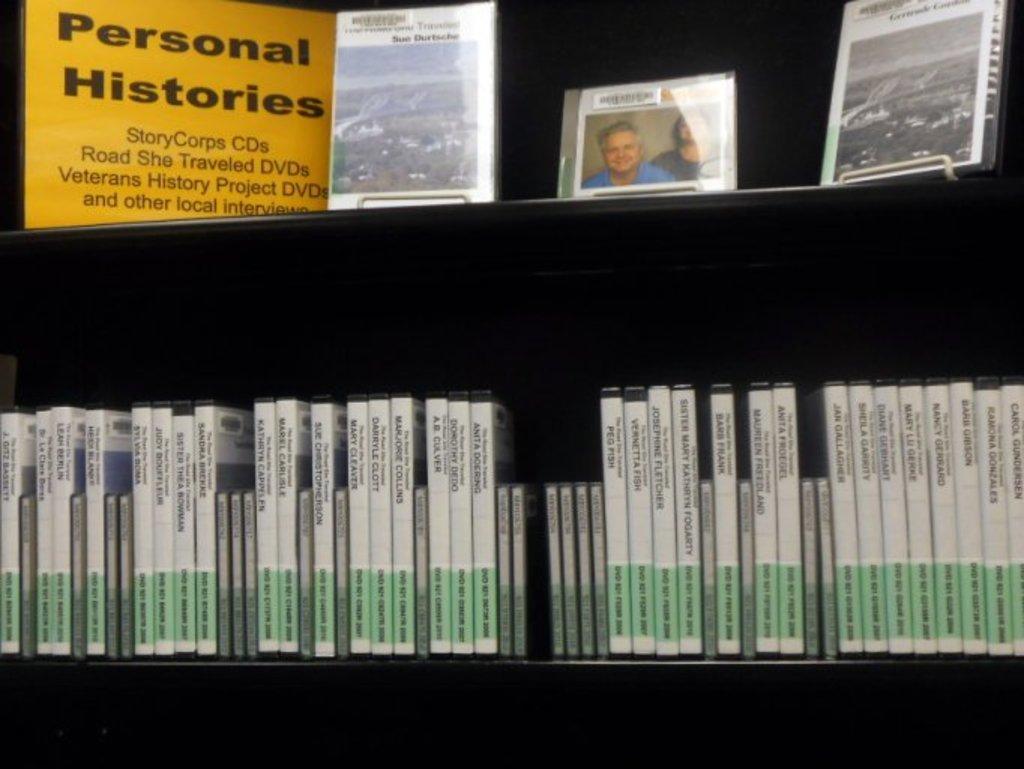In one or two sentences, can you explain what this image depicts? In this image I can see number of green and white colour things over here. On these things I can see something is written. I can also see a yellow color thing, a frame and few other stuffs. On these things I can see something is written. 